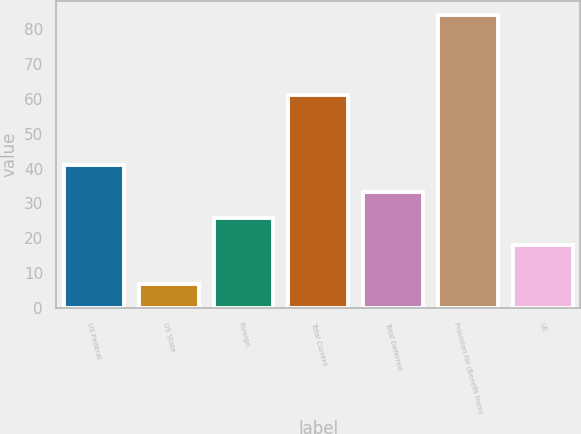<chart> <loc_0><loc_0><loc_500><loc_500><bar_chart><fcel>US Federal<fcel>US State<fcel>Foreign<fcel>Total Current<fcel>Total Deferred<fcel>Provision for (Benefit from)<fcel>US<nl><fcel>41.1<fcel>7<fcel>25.7<fcel>61<fcel>33.4<fcel>84<fcel>18<nl></chart> 